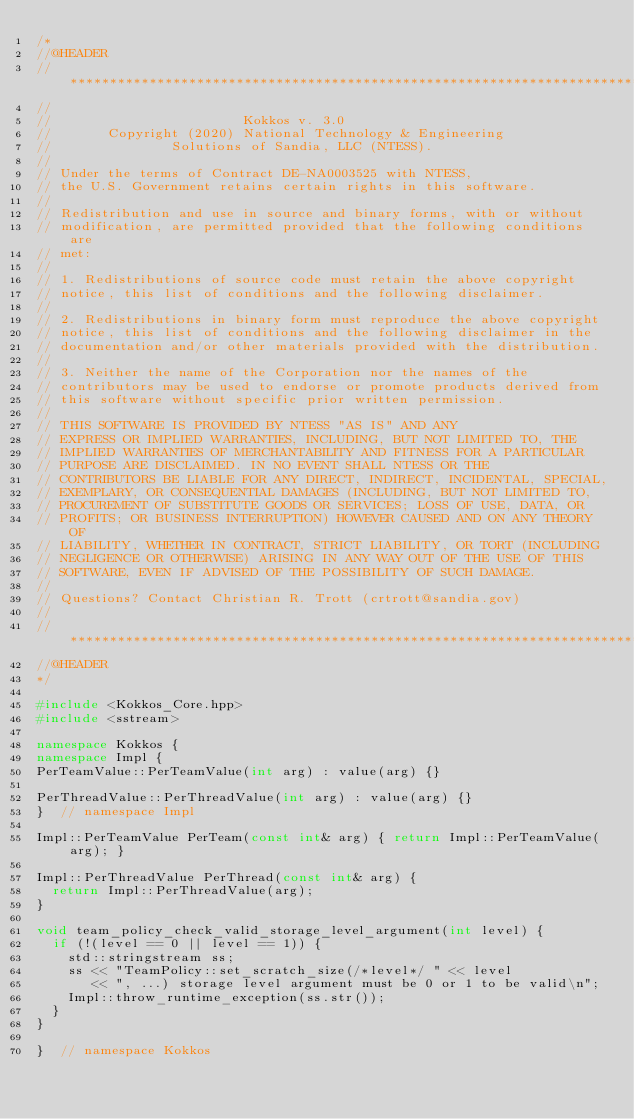Convert code to text. <code><loc_0><loc_0><loc_500><loc_500><_C++_>/*
//@HEADER
// ************************************************************************
//
//                        Kokkos v. 3.0
//       Copyright (2020) National Technology & Engineering
//               Solutions of Sandia, LLC (NTESS).
//
// Under the terms of Contract DE-NA0003525 with NTESS,
// the U.S. Government retains certain rights in this software.
//
// Redistribution and use in source and binary forms, with or without
// modification, are permitted provided that the following conditions are
// met:
//
// 1. Redistributions of source code must retain the above copyright
// notice, this list of conditions and the following disclaimer.
//
// 2. Redistributions in binary form must reproduce the above copyright
// notice, this list of conditions and the following disclaimer in the
// documentation and/or other materials provided with the distribution.
//
// 3. Neither the name of the Corporation nor the names of the
// contributors may be used to endorse or promote products derived from
// this software without specific prior written permission.
//
// THIS SOFTWARE IS PROVIDED BY NTESS "AS IS" AND ANY
// EXPRESS OR IMPLIED WARRANTIES, INCLUDING, BUT NOT LIMITED TO, THE
// IMPLIED WARRANTIES OF MERCHANTABILITY AND FITNESS FOR A PARTICULAR
// PURPOSE ARE DISCLAIMED. IN NO EVENT SHALL NTESS OR THE
// CONTRIBUTORS BE LIABLE FOR ANY DIRECT, INDIRECT, INCIDENTAL, SPECIAL,
// EXEMPLARY, OR CONSEQUENTIAL DAMAGES (INCLUDING, BUT NOT LIMITED TO,
// PROCUREMENT OF SUBSTITUTE GOODS OR SERVICES; LOSS OF USE, DATA, OR
// PROFITS; OR BUSINESS INTERRUPTION) HOWEVER CAUSED AND ON ANY THEORY OF
// LIABILITY, WHETHER IN CONTRACT, STRICT LIABILITY, OR TORT (INCLUDING
// NEGLIGENCE OR OTHERWISE) ARISING IN ANY WAY OUT OF THE USE OF THIS
// SOFTWARE, EVEN IF ADVISED OF THE POSSIBILITY OF SUCH DAMAGE.
//
// Questions? Contact Christian R. Trott (crtrott@sandia.gov)
//
// ************************************************************************
//@HEADER
*/

#include <Kokkos_Core.hpp>
#include <sstream>

namespace Kokkos {
namespace Impl {
PerTeamValue::PerTeamValue(int arg) : value(arg) {}

PerThreadValue::PerThreadValue(int arg) : value(arg) {}
}  // namespace Impl

Impl::PerTeamValue PerTeam(const int& arg) { return Impl::PerTeamValue(arg); }

Impl::PerThreadValue PerThread(const int& arg) {
  return Impl::PerThreadValue(arg);
}

void team_policy_check_valid_storage_level_argument(int level) {
  if (!(level == 0 || level == 1)) {
    std::stringstream ss;
    ss << "TeamPolicy::set_scratch_size(/*level*/ " << level
       << ", ...) storage level argument must be 0 or 1 to be valid\n";
    Impl::throw_runtime_exception(ss.str());
  }
}

}  // namespace Kokkos
</code> 